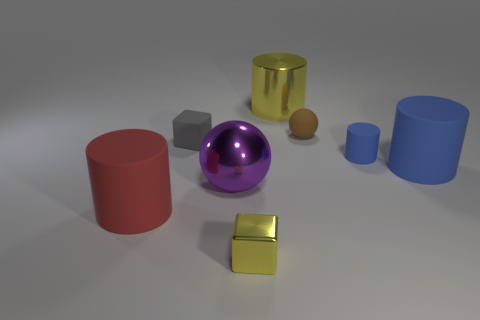There is a object that is to the right of the gray cube and in front of the large ball; what is its shape?
Keep it short and to the point. Cube. What number of other objects are the same shape as the small blue rubber thing?
Ensure brevity in your answer.  3. The rubber block that is the same size as the brown thing is what color?
Your answer should be very brief. Gray. What number of things are either large purple things or big purple metal cubes?
Your answer should be very brief. 1. There is a metallic cube; are there any red matte things left of it?
Offer a very short reply. Yes. Is there a large thing made of the same material as the large ball?
Give a very brief answer. Yes. The metallic thing that is the same color as the metallic cube is what size?
Ensure brevity in your answer.  Large. How many cylinders are either matte things or big purple shiny things?
Offer a very short reply. 3. Are there more tiny matte cubes in front of the metal ball than large blue things behind the tiny blue matte thing?
Your answer should be compact. No. What number of small metallic things have the same color as the big metal cylinder?
Give a very brief answer. 1. 